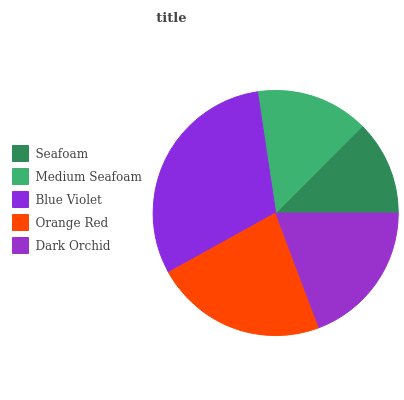Is Seafoam the minimum?
Answer yes or no. Yes. Is Blue Violet the maximum?
Answer yes or no. Yes. Is Medium Seafoam the minimum?
Answer yes or no. No. Is Medium Seafoam the maximum?
Answer yes or no. No. Is Medium Seafoam greater than Seafoam?
Answer yes or no. Yes. Is Seafoam less than Medium Seafoam?
Answer yes or no. Yes. Is Seafoam greater than Medium Seafoam?
Answer yes or no. No. Is Medium Seafoam less than Seafoam?
Answer yes or no. No. Is Dark Orchid the high median?
Answer yes or no. Yes. Is Dark Orchid the low median?
Answer yes or no. Yes. Is Seafoam the high median?
Answer yes or no. No. Is Medium Seafoam the low median?
Answer yes or no. No. 